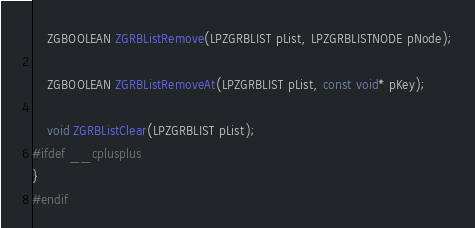Convert code to text. <code><loc_0><loc_0><loc_500><loc_500><_C_>	ZGBOOLEAN ZGRBListRemove(LPZGRBLIST pList, LPZGRBLISTNODE pNode);

	ZGBOOLEAN ZGRBListRemoveAt(LPZGRBLIST pList, const void* pKey);

	void ZGRBListClear(LPZGRBLIST pList);
#ifdef __cplusplus
}
#endif

</code> 